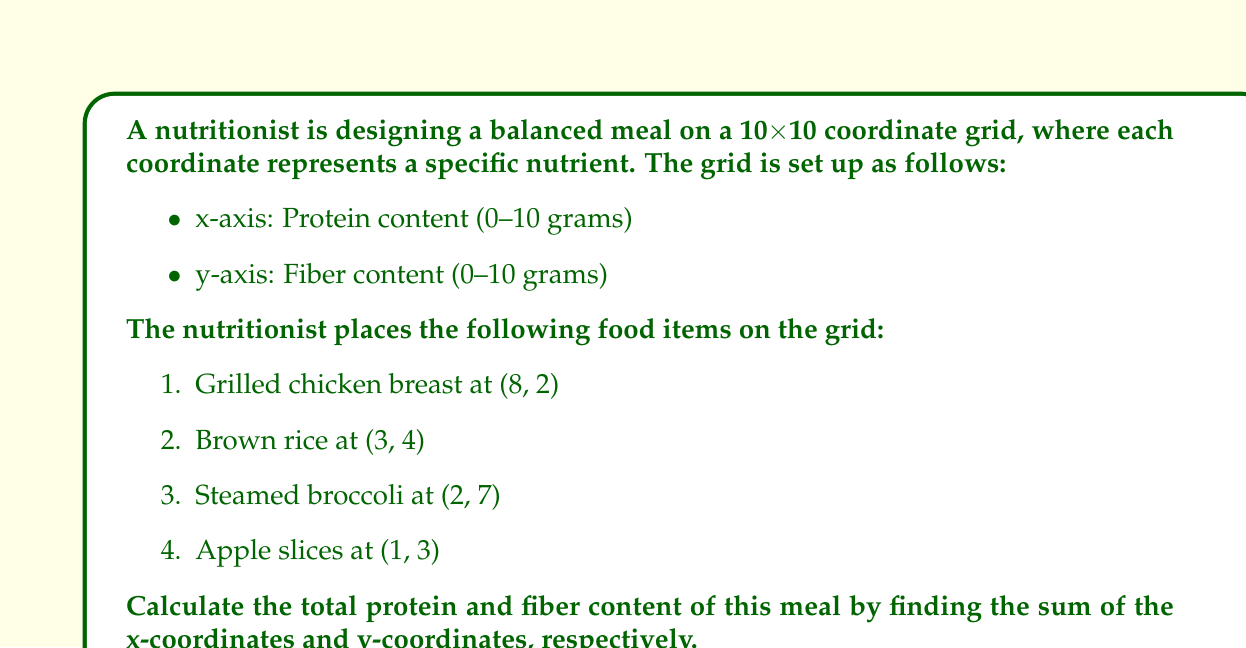Solve this math problem. To solve this problem, we need to follow these steps:

1. Identify the x-coordinates (protein content) and y-coordinates (fiber content) for each food item:
   - Grilled chicken breast: (8, 2)
   - Brown rice: (3, 4)
   - Steamed broccoli: (2, 7)
   - Apple slices: (1, 3)

2. Sum up the x-coordinates to find the total protein content:
   $$ \text{Total Protein} = 8 + 3 + 2 + 1 = 14 \text{ grams} $$

3. Sum up the y-coordinates to find the total fiber content:
   $$ \text{Total Fiber} = 2 + 4 + 7 + 3 = 16 \text{ grams} $$

This method allows us to quickly calculate the nutrient distribution in the meal using the coordinate system. It demonstrates how coordinate grids can be used to visualize and analyze nutritional content, which is valuable for healthcare professionals and nutrition education.
Answer: The balanced meal contains a total of 14 grams of protein and 16 grams of fiber. 